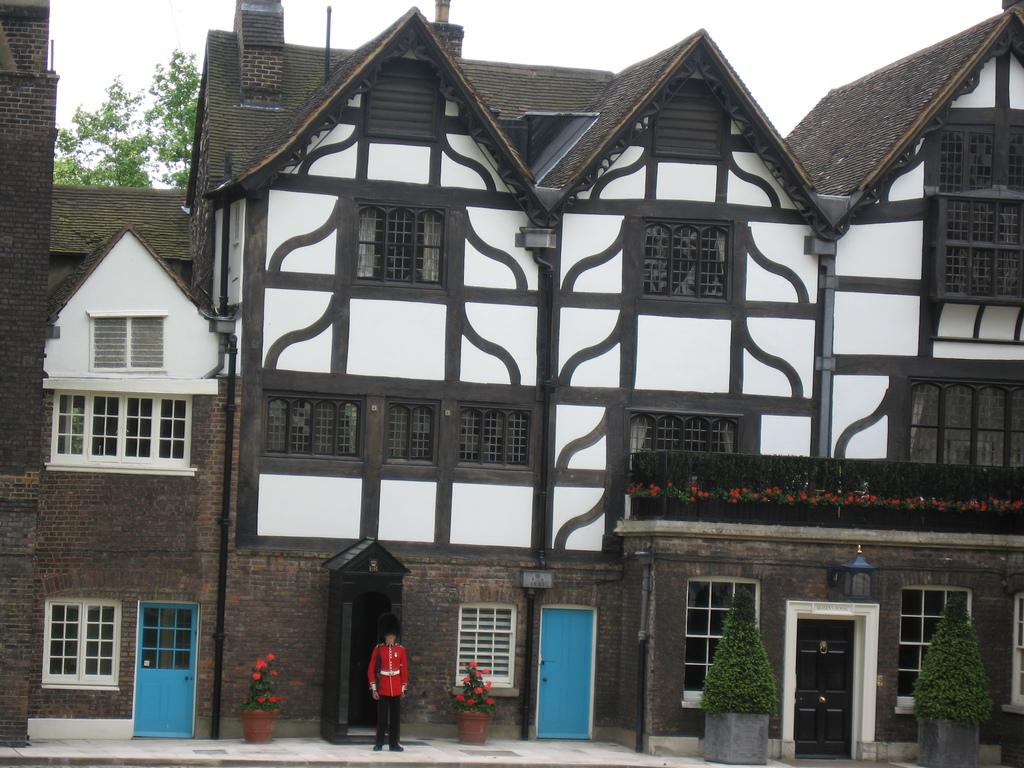What type of structures can be seen in the image? There are buildings in the image. What type of plants are present in the image? There are flower pots and a tree in the image. What else can be seen in the image besides buildings and plants? There are other objects in the image. What is visible in the background of the image? The sky is visible in the background of the image. What type of disease is affecting the tomatoes in the image? There are no tomatoes present in the image, so it is not possible to determine if any disease is affecting them. 